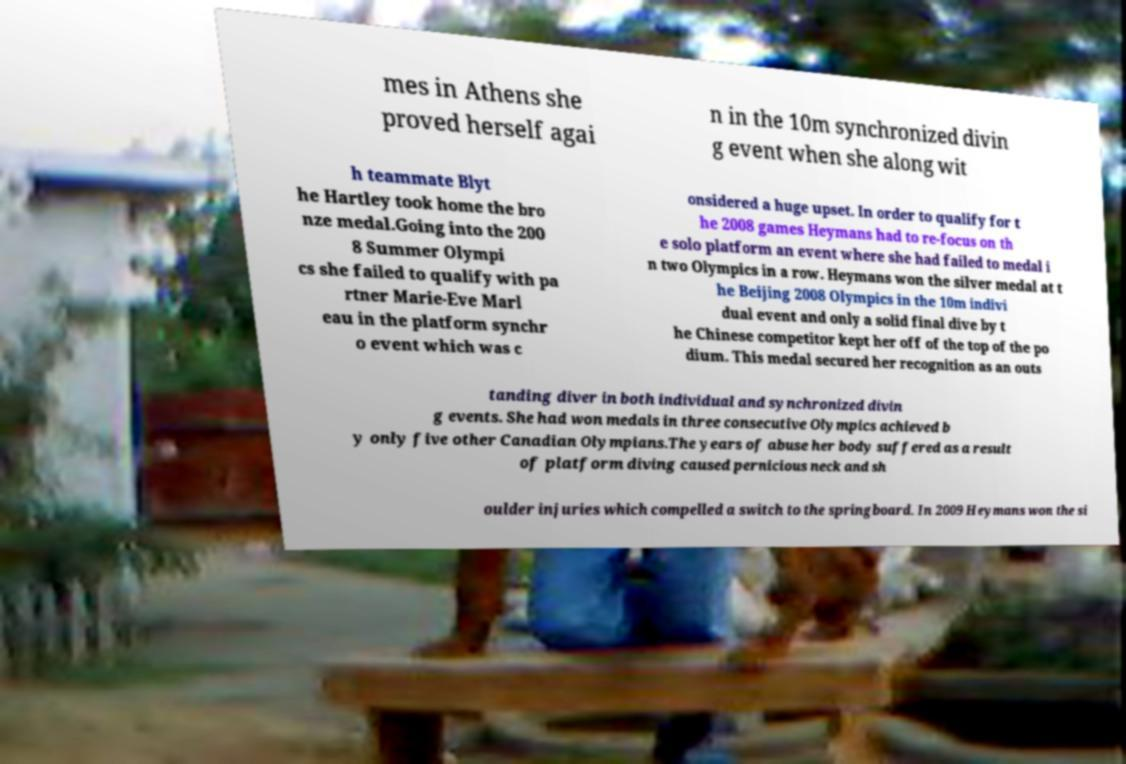There's text embedded in this image that I need extracted. Can you transcribe it verbatim? mes in Athens she proved herself agai n in the 10m synchronized divin g event when she along wit h teammate Blyt he Hartley took home the bro nze medal.Going into the 200 8 Summer Olympi cs she failed to qualify with pa rtner Marie-Eve Marl eau in the platform synchr o event which was c onsidered a huge upset. In order to qualify for t he 2008 games Heymans had to re-focus on th e solo platform an event where she had failed to medal i n two Olympics in a row. Heymans won the silver medal at t he Beijing 2008 Olympics in the 10m indivi dual event and only a solid final dive by t he Chinese competitor kept her off of the top of the po dium. This medal secured her recognition as an outs tanding diver in both individual and synchronized divin g events. She had won medals in three consecutive Olympics achieved b y only five other Canadian Olympians.The years of abuse her body suffered as a result of platform diving caused pernicious neck and sh oulder injuries which compelled a switch to the springboard. In 2009 Heymans won the si 